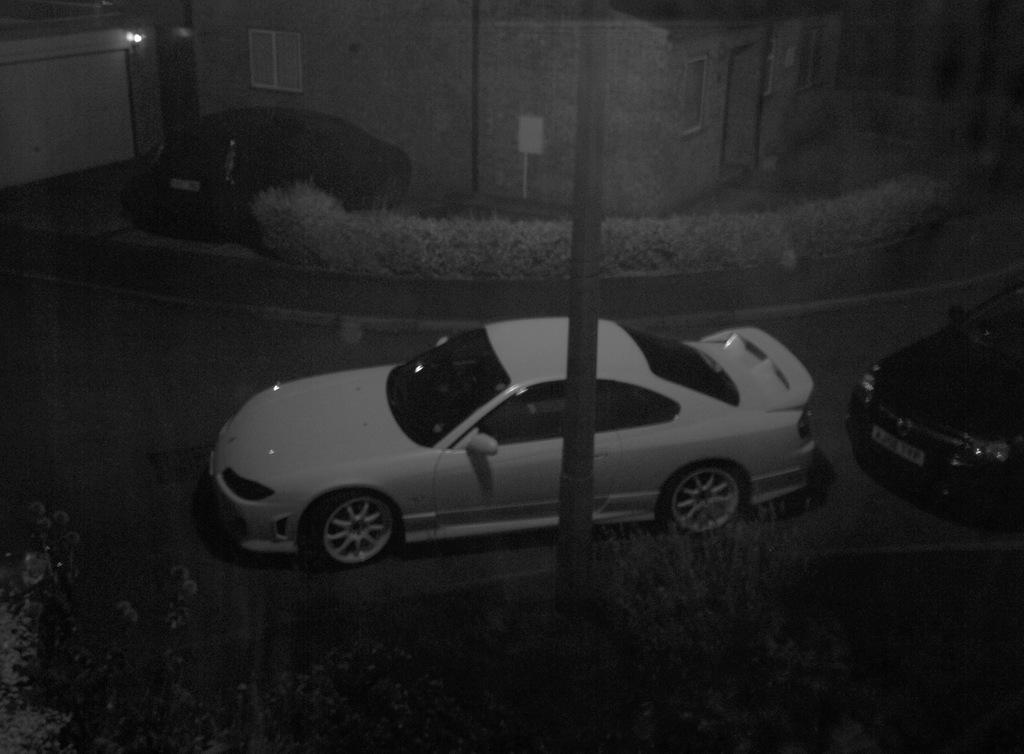What is located in front of the image? There are plants in front of the image. What can be seen in the image besides the plants? There is a pole, cars, bushes, buildings, a board, and lights on the left side of the image. What type of structure is visible in the image? There are buildings in the image. What is attached to the pole in the image? The board is attached to the pole in the image. How many apples are on the board in the image? There are no apples present in the image; the board is attached to a pole. What type of office can be seen in the image? There is no office present in the image. Can you see a rat in the image? There is no rat present in the image. 